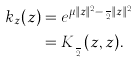<formula> <loc_0><loc_0><loc_500><loc_500>k _ { z } ( z ) & = e ^ { \mu \| z \| ^ { 2 } - \frac { \mu } { 2 } \| z \| ^ { 2 } } \\ & = K _ { \frac { \mu } { 2 } } ( z , z ) .</formula> 